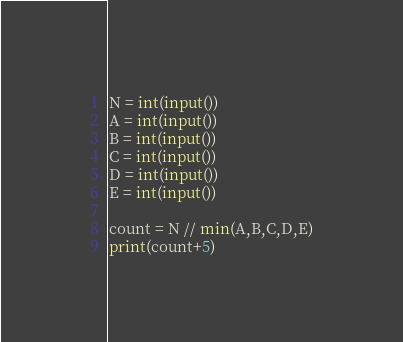<code> <loc_0><loc_0><loc_500><loc_500><_Python_>N = int(input())
A = int(input())
B = int(input())
C = int(input())
D = int(input())
E = int(input())

count = N // min(A,B,C,D,E)
print(count+5)</code> 